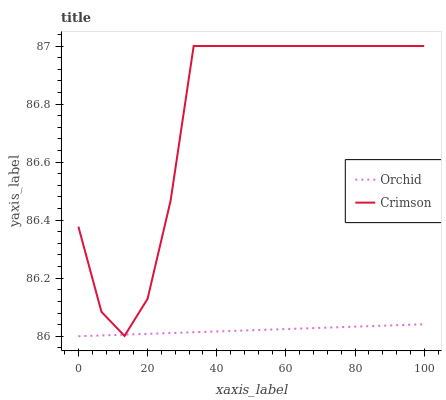Does Orchid have the minimum area under the curve?
Answer yes or no. Yes. Does Crimson have the maximum area under the curve?
Answer yes or no. Yes. Does Orchid have the maximum area under the curve?
Answer yes or no. No. Is Orchid the smoothest?
Answer yes or no. Yes. Is Crimson the roughest?
Answer yes or no. Yes. Is Orchid the roughest?
Answer yes or no. No. Does Crimson have the highest value?
Answer yes or no. Yes. Does Orchid have the highest value?
Answer yes or no. No. Does Orchid intersect Crimson?
Answer yes or no. Yes. Is Orchid less than Crimson?
Answer yes or no. No. Is Orchid greater than Crimson?
Answer yes or no. No. 